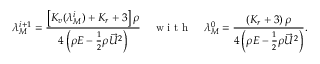Convert formula to latex. <formula><loc_0><loc_0><loc_500><loc_500>\lambda _ { M } ^ { i + 1 } = \frac { \left [ K _ { v } ( \lambda _ { M } ^ { i } ) + K _ { r } + 3 \right ] \rho } { 4 \left ( \rho E - \frac { 1 } { 2 } \rho \vec { U } ^ { 2 } \right ) } \quad w i t h \quad \lambda _ { M } ^ { 0 } = \frac { \left ( K _ { r } + 3 \right ) \rho } { 4 \left ( \rho E - \frac { 1 } { 2 } \rho \vec { U } ^ { 2 } \right ) } .</formula> 